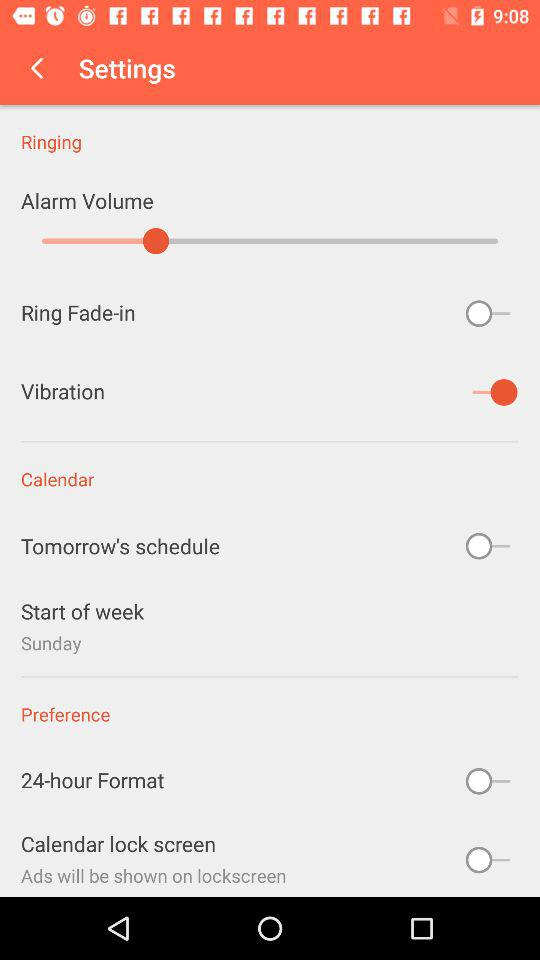How many alarms are there?
Answer the question using a single word or phrase. 3 